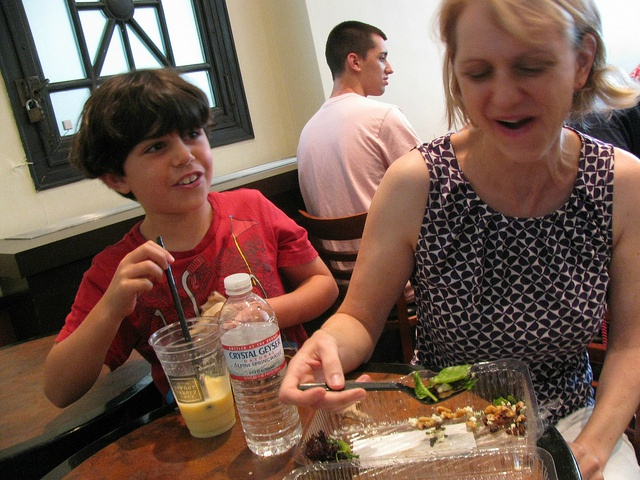Describe the objects in this image and their specific colors. I can see people in black, brown, maroon, and gray tones, people in black, maroon, and brown tones, people in black, brown, lightgray, and lightpink tones, dining table in black, maroon, and brown tones, and bottle in black, brown, darkgray, and tan tones in this image. 